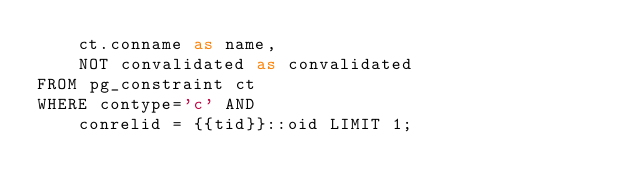<code> <loc_0><loc_0><loc_500><loc_500><_SQL_>    ct.conname as name,
    NOT convalidated as convalidated
FROM pg_constraint ct
WHERE contype='c' AND
    conrelid = {{tid}}::oid LIMIT 1;</code> 